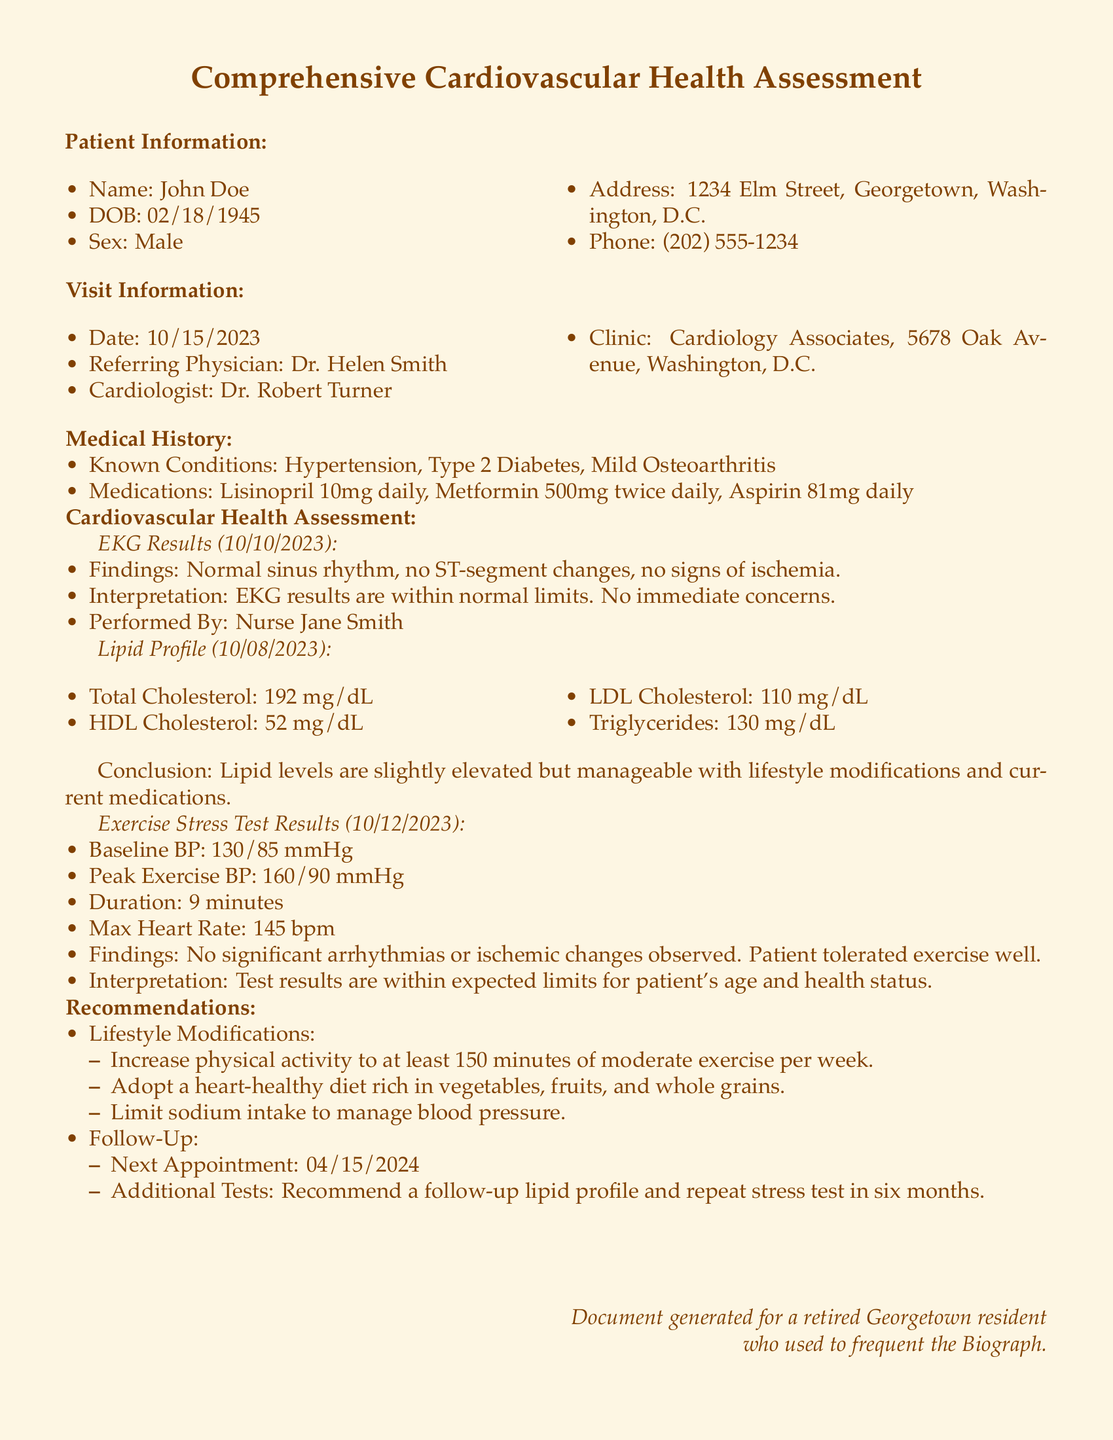What is the patient's name? The patient's name is located in the Patient Information section.
Answer: John Doe What is the date of the visit? The date of the visit can be found in the Visit Information section.
Answer: 10/15/2023 What is the total cholesterol level? The total cholesterol level is part of the Lipid Profile results in the document.
Answer: 192 mg/dL What was the patient's peak exercise blood pressure? Peak exercise blood pressure information is included in the Exercise Stress Test Results.
Answer: 160/90 mmHg What recommendations were made regarding physical activity? Recommendations for physical activity are stated in the Recommendations section.
Answer: Increase physical activity to at least 150 minutes of moderate exercise per week What is the interpretation of the EKG results? The interpretation of the EKG results is provided in the Cardiovascular Health Assessment section.
Answer: EKG results are within normal limits When is the next appointment scheduled? The next appointment date can be found in the Follow-Up part of the document.
Answer: 04/15/2024 What type of diet is recommended? The type of diet recommended is included in the Lifestyle Modifications subsection.
Answer: Heart-healthy diet rich in vegetables, fruits, and whole grains 